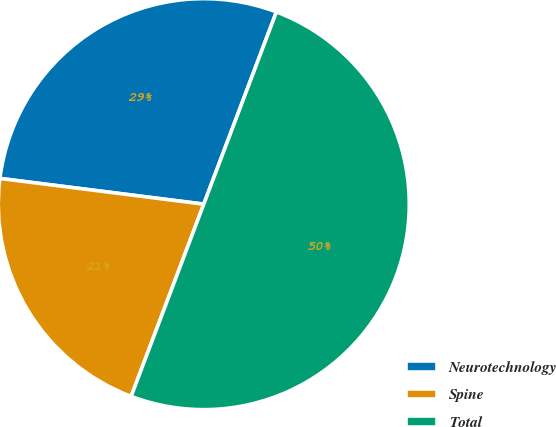<chart> <loc_0><loc_0><loc_500><loc_500><pie_chart><fcel>Neurotechnology<fcel>Spine<fcel>Total<nl><fcel>28.75%<fcel>21.25%<fcel>50.0%<nl></chart> 